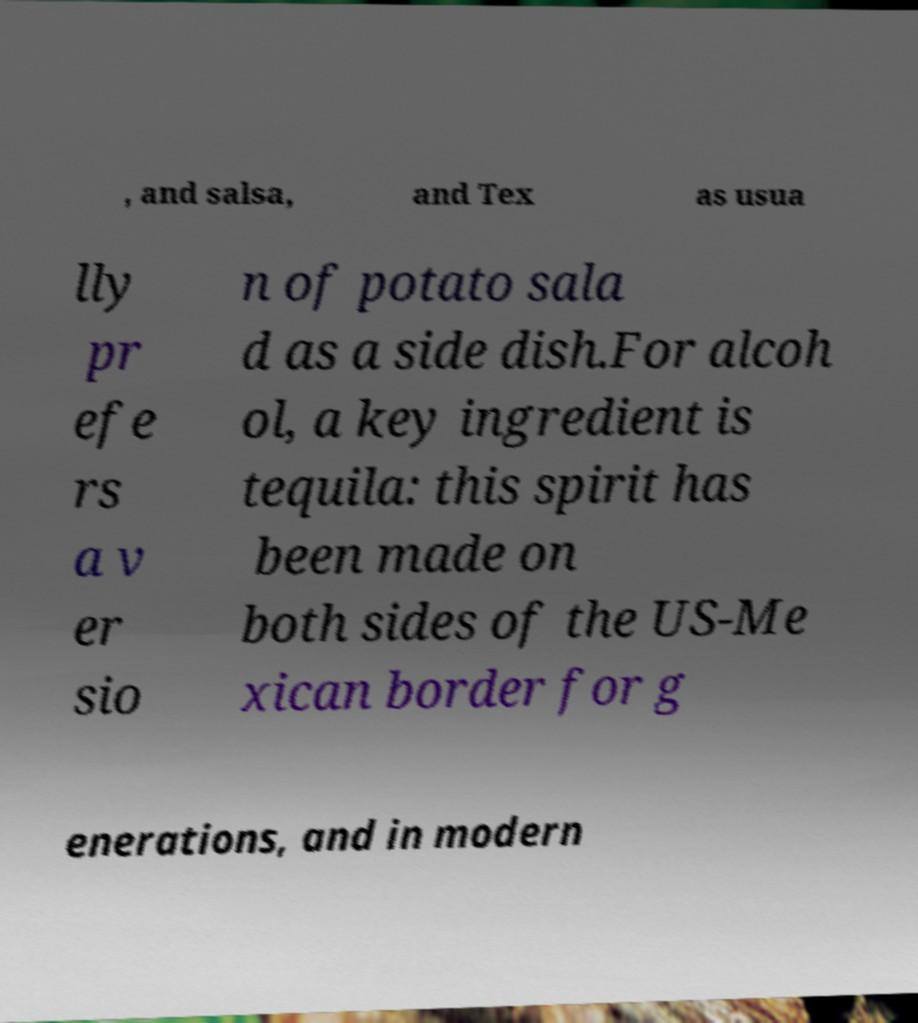Please read and relay the text visible in this image. What does it say? , and salsa, and Tex as usua lly pr efe rs a v er sio n of potato sala d as a side dish.For alcoh ol, a key ingredient is tequila: this spirit has been made on both sides of the US-Me xican border for g enerations, and in modern 